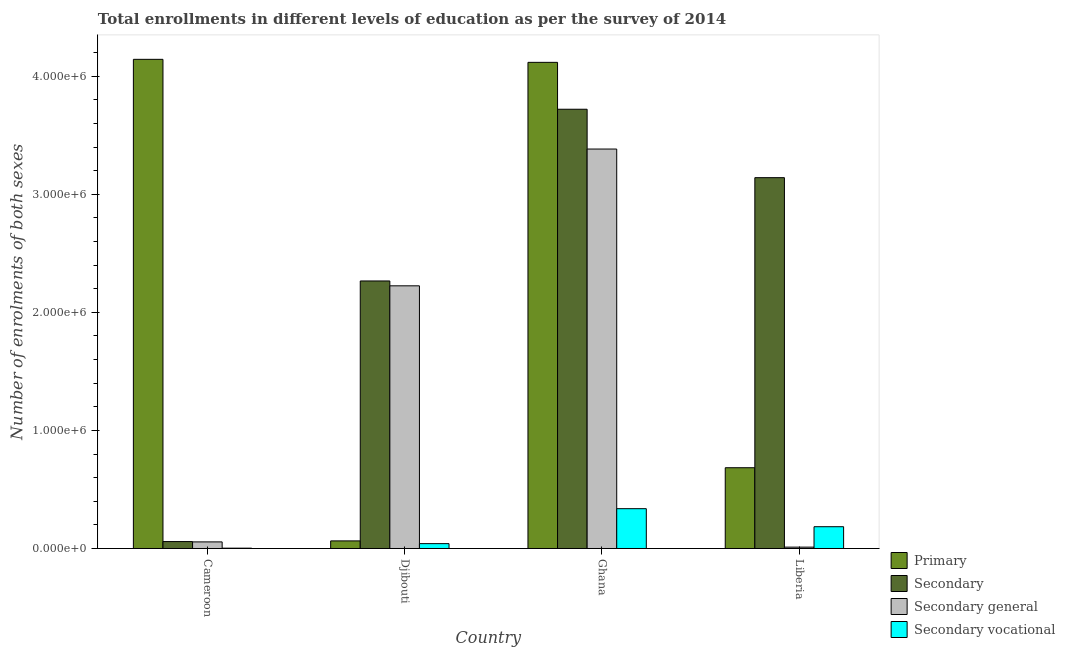Are the number of bars per tick equal to the number of legend labels?
Offer a terse response. Yes. Are the number of bars on each tick of the X-axis equal?
Your answer should be very brief. Yes. What is the label of the 4th group of bars from the left?
Make the answer very short. Liberia. What is the number of enrolments in secondary vocational education in Ghana?
Keep it short and to the point. 3.37e+05. Across all countries, what is the maximum number of enrolments in secondary education?
Give a very brief answer. 3.72e+06. Across all countries, what is the minimum number of enrolments in secondary education?
Make the answer very short. 5.86e+04. In which country was the number of enrolments in secondary education maximum?
Provide a short and direct response. Ghana. In which country was the number of enrolments in secondary vocational education minimum?
Provide a short and direct response. Cameroon. What is the total number of enrolments in secondary vocational education in the graph?
Your answer should be compact. 5.65e+05. What is the difference between the number of enrolments in secondary education in Cameroon and that in Liberia?
Make the answer very short. -3.08e+06. What is the difference between the number of enrolments in secondary vocational education in Ghana and the number of enrolments in secondary education in Djibouti?
Your response must be concise. -1.93e+06. What is the average number of enrolments in primary education per country?
Provide a succinct answer. 2.25e+06. What is the difference between the number of enrolments in primary education and number of enrolments in secondary general education in Cameroon?
Make the answer very short. 4.09e+06. What is the ratio of the number of enrolments in secondary education in Cameroon to that in Liberia?
Give a very brief answer. 0.02. Is the difference between the number of enrolments in secondary education in Ghana and Liberia greater than the difference between the number of enrolments in secondary general education in Ghana and Liberia?
Ensure brevity in your answer.  No. What is the difference between the highest and the second highest number of enrolments in secondary education?
Make the answer very short. 5.80e+05. What is the difference between the highest and the lowest number of enrolments in secondary education?
Make the answer very short. 3.66e+06. In how many countries, is the number of enrolments in secondary vocational education greater than the average number of enrolments in secondary vocational education taken over all countries?
Offer a terse response. 2. Is it the case that in every country, the sum of the number of enrolments in secondary education and number of enrolments in secondary vocational education is greater than the sum of number of enrolments in primary education and number of enrolments in secondary general education?
Offer a terse response. No. What does the 1st bar from the left in Djibouti represents?
Ensure brevity in your answer.  Primary. What does the 1st bar from the right in Djibouti represents?
Your response must be concise. Secondary vocational. Is it the case that in every country, the sum of the number of enrolments in primary education and number of enrolments in secondary education is greater than the number of enrolments in secondary general education?
Ensure brevity in your answer.  Yes. How many bars are there?
Make the answer very short. 16. Are all the bars in the graph horizontal?
Keep it short and to the point. No. Are the values on the major ticks of Y-axis written in scientific E-notation?
Give a very brief answer. Yes. Does the graph contain any zero values?
Your response must be concise. No. Where does the legend appear in the graph?
Provide a succinct answer. Bottom right. How many legend labels are there?
Make the answer very short. 4. How are the legend labels stacked?
Offer a terse response. Vertical. What is the title of the graph?
Provide a succinct answer. Total enrollments in different levels of education as per the survey of 2014. What is the label or title of the X-axis?
Ensure brevity in your answer.  Country. What is the label or title of the Y-axis?
Make the answer very short. Number of enrolments of both sexes. What is the Number of enrolments of both sexes in Primary in Cameroon?
Give a very brief answer. 4.14e+06. What is the Number of enrolments of both sexes in Secondary in Cameroon?
Ensure brevity in your answer.  5.86e+04. What is the Number of enrolments of both sexes of Secondary general in Cameroon?
Provide a succinct answer. 5.58e+04. What is the Number of enrolments of both sexes of Secondary vocational in Cameroon?
Provide a short and direct response. 2728. What is the Number of enrolments of both sexes in Primary in Djibouti?
Provide a short and direct response. 6.43e+04. What is the Number of enrolments of both sexes of Secondary in Djibouti?
Make the answer very short. 2.27e+06. What is the Number of enrolments of both sexes in Secondary general in Djibouti?
Your response must be concise. 2.22e+06. What is the Number of enrolments of both sexes in Secondary vocational in Djibouti?
Give a very brief answer. 4.11e+04. What is the Number of enrolments of both sexes of Primary in Ghana?
Provide a short and direct response. 4.12e+06. What is the Number of enrolments of both sexes in Secondary in Ghana?
Offer a terse response. 3.72e+06. What is the Number of enrolments of both sexes in Secondary general in Ghana?
Keep it short and to the point. 3.38e+06. What is the Number of enrolments of both sexes in Secondary vocational in Ghana?
Your answer should be compact. 3.37e+05. What is the Number of enrolments of both sexes in Primary in Liberia?
Make the answer very short. 6.84e+05. What is the Number of enrolments of both sexes in Secondary in Liberia?
Your response must be concise. 3.14e+06. What is the Number of enrolments of both sexes in Secondary general in Liberia?
Give a very brief answer. 1.14e+04. What is the Number of enrolments of both sexes of Secondary vocational in Liberia?
Your answer should be very brief. 1.84e+05. Across all countries, what is the maximum Number of enrolments of both sexes in Primary?
Your response must be concise. 4.14e+06. Across all countries, what is the maximum Number of enrolments of both sexes of Secondary?
Give a very brief answer. 3.72e+06. Across all countries, what is the maximum Number of enrolments of both sexes in Secondary general?
Make the answer very short. 3.38e+06. Across all countries, what is the maximum Number of enrolments of both sexes in Secondary vocational?
Your answer should be compact. 3.37e+05. Across all countries, what is the minimum Number of enrolments of both sexes in Primary?
Offer a very short reply. 6.43e+04. Across all countries, what is the minimum Number of enrolments of both sexes in Secondary?
Give a very brief answer. 5.86e+04. Across all countries, what is the minimum Number of enrolments of both sexes of Secondary general?
Your response must be concise. 1.14e+04. Across all countries, what is the minimum Number of enrolments of both sexes in Secondary vocational?
Keep it short and to the point. 2728. What is the total Number of enrolments of both sexes of Primary in the graph?
Make the answer very short. 9.01e+06. What is the total Number of enrolments of both sexes in Secondary in the graph?
Make the answer very short. 9.18e+06. What is the total Number of enrolments of both sexes in Secondary general in the graph?
Make the answer very short. 5.67e+06. What is the total Number of enrolments of both sexes of Secondary vocational in the graph?
Offer a terse response. 5.65e+05. What is the difference between the Number of enrolments of both sexes of Primary in Cameroon and that in Djibouti?
Give a very brief answer. 4.08e+06. What is the difference between the Number of enrolments of both sexes in Secondary in Cameroon and that in Djibouti?
Make the answer very short. -2.21e+06. What is the difference between the Number of enrolments of both sexes in Secondary general in Cameroon and that in Djibouti?
Give a very brief answer. -2.17e+06. What is the difference between the Number of enrolments of both sexes of Secondary vocational in Cameroon and that in Djibouti?
Your response must be concise. -3.83e+04. What is the difference between the Number of enrolments of both sexes of Primary in Cameroon and that in Ghana?
Your response must be concise. 2.56e+04. What is the difference between the Number of enrolments of both sexes in Secondary in Cameroon and that in Ghana?
Offer a terse response. -3.66e+06. What is the difference between the Number of enrolments of both sexes in Secondary general in Cameroon and that in Ghana?
Your response must be concise. -3.33e+06. What is the difference between the Number of enrolments of both sexes of Secondary vocational in Cameroon and that in Ghana?
Provide a succinct answer. -3.34e+05. What is the difference between the Number of enrolments of both sexes of Primary in Cameroon and that in Liberia?
Provide a succinct answer. 3.46e+06. What is the difference between the Number of enrolments of both sexes of Secondary in Cameroon and that in Liberia?
Provide a short and direct response. -3.08e+06. What is the difference between the Number of enrolments of both sexes of Secondary general in Cameroon and that in Liberia?
Ensure brevity in your answer.  4.44e+04. What is the difference between the Number of enrolments of both sexes in Secondary vocational in Cameroon and that in Liberia?
Your answer should be compact. -1.82e+05. What is the difference between the Number of enrolments of both sexes in Primary in Djibouti and that in Ghana?
Make the answer very short. -4.05e+06. What is the difference between the Number of enrolments of both sexes in Secondary in Djibouti and that in Ghana?
Keep it short and to the point. -1.45e+06. What is the difference between the Number of enrolments of both sexes in Secondary general in Djibouti and that in Ghana?
Give a very brief answer. -1.16e+06. What is the difference between the Number of enrolments of both sexes in Secondary vocational in Djibouti and that in Ghana?
Offer a terse response. -2.96e+05. What is the difference between the Number of enrolments of both sexes in Primary in Djibouti and that in Liberia?
Your answer should be compact. -6.20e+05. What is the difference between the Number of enrolments of both sexes in Secondary in Djibouti and that in Liberia?
Your response must be concise. -8.75e+05. What is the difference between the Number of enrolments of both sexes in Secondary general in Djibouti and that in Liberia?
Give a very brief answer. 2.21e+06. What is the difference between the Number of enrolments of both sexes in Secondary vocational in Djibouti and that in Liberia?
Ensure brevity in your answer.  -1.43e+05. What is the difference between the Number of enrolments of both sexes of Primary in Ghana and that in Liberia?
Provide a short and direct response. 3.43e+06. What is the difference between the Number of enrolments of both sexes in Secondary in Ghana and that in Liberia?
Make the answer very short. 5.80e+05. What is the difference between the Number of enrolments of both sexes in Secondary general in Ghana and that in Liberia?
Your response must be concise. 3.37e+06. What is the difference between the Number of enrolments of both sexes in Secondary vocational in Ghana and that in Liberia?
Provide a short and direct response. 1.53e+05. What is the difference between the Number of enrolments of both sexes in Primary in Cameroon and the Number of enrolments of both sexes in Secondary in Djibouti?
Give a very brief answer. 1.88e+06. What is the difference between the Number of enrolments of both sexes in Primary in Cameroon and the Number of enrolments of both sexes in Secondary general in Djibouti?
Your answer should be compact. 1.92e+06. What is the difference between the Number of enrolments of both sexes of Primary in Cameroon and the Number of enrolments of both sexes of Secondary vocational in Djibouti?
Ensure brevity in your answer.  4.10e+06. What is the difference between the Number of enrolments of both sexes of Secondary in Cameroon and the Number of enrolments of both sexes of Secondary general in Djibouti?
Your answer should be compact. -2.17e+06. What is the difference between the Number of enrolments of both sexes in Secondary in Cameroon and the Number of enrolments of both sexes in Secondary vocational in Djibouti?
Give a very brief answer. 1.75e+04. What is the difference between the Number of enrolments of both sexes of Secondary general in Cameroon and the Number of enrolments of both sexes of Secondary vocational in Djibouti?
Provide a short and direct response. 1.48e+04. What is the difference between the Number of enrolments of both sexes of Primary in Cameroon and the Number of enrolments of both sexes of Secondary in Ghana?
Offer a very short reply. 4.23e+05. What is the difference between the Number of enrolments of both sexes of Primary in Cameroon and the Number of enrolments of both sexes of Secondary general in Ghana?
Make the answer very short. 7.60e+05. What is the difference between the Number of enrolments of both sexes in Primary in Cameroon and the Number of enrolments of both sexes in Secondary vocational in Ghana?
Offer a very short reply. 3.81e+06. What is the difference between the Number of enrolments of both sexes in Secondary in Cameroon and the Number of enrolments of both sexes in Secondary general in Ghana?
Keep it short and to the point. -3.32e+06. What is the difference between the Number of enrolments of both sexes of Secondary in Cameroon and the Number of enrolments of both sexes of Secondary vocational in Ghana?
Your answer should be compact. -2.79e+05. What is the difference between the Number of enrolments of both sexes in Secondary general in Cameroon and the Number of enrolments of both sexes in Secondary vocational in Ghana?
Provide a succinct answer. -2.81e+05. What is the difference between the Number of enrolments of both sexes of Primary in Cameroon and the Number of enrolments of both sexes of Secondary in Liberia?
Your response must be concise. 1.00e+06. What is the difference between the Number of enrolments of both sexes of Primary in Cameroon and the Number of enrolments of both sexes of Secondary general in Liberia?
Offer a very short reply. 4.13e+06. What is the difference between the Number of enrolments of both sexes in Primary in Cameroon and the Number of enrolments of both sexes in Secondary vocational in Liberia?
Your answer should be very brief. 3.96e+06. What is the difference between the Number of enrolments of both sexes in Secondary in Cameroon and the Number of enrolments of both sexes in Secondary general in Liberia?
Provide a succinct answer. 4.71e+04. What is the difference between the Number of enrolments of both sexes in Secondary in Cameroon and the Number of enrolments of both sexes in Secondary vocational in Liberia?
Provide a short and direct response. -1.26e+05. What is the difference between the Number of enrolments of both sexes in Secondary general in Cameroon and the Number of enrolments of both sexes in Secondary vocational in Liberia?
Offer a terse response. -1.29e+05. What is the difference between the Number of enrolments of both sexes of Primary in Djibouti and the Number of enrolments of both sexes of Secondary in Ghana?
Give a very brief answer. -3.66e+06. What is the difference between the Number of enrolments of both sexes in Primary in Djibouti and the Number of enrolments of both sexes in Secondary general in Ghana?
Keep it short and to the point. -3.32e+06. What is the difference between the Number of enrolments of both sexes of Primary in Djibouti and the Number of enrolments of both sexes of Secondary vocational in Ghana?
Keep it short and to the point. -2.73e+05. What is the difference between the Number of enrolments of both sexes of Secondary in Djibouti and the Number of enrolments of both sexes of Secondary general in Ghana?
Offer a very short reply. -1.12e+06. What is the difference between the Number of enrolments of both sexes of Secondary in Djibouti and the Number of enrolments of both sexes of Secondary vocational in Ghana?
Give a very brief answer. 1.93e+06. What is the difference between the Number of enrolments of both sexes in Secondary general in Djibouti and the Number of enrolments of both sexes in Secondary vocational in Ghana?
Offer a terse response. 1.89e+06. What is the difference between the Number of enrolments of both sexes of Primary in Djibouti and the Number of enrolments of both sexes of Secondary in Liberia?
Provide a short and direct response. -3.08e+06. What is the difference between the Number of enrolments of both sexes in Primary in Djibouti and the Number of enrolments of both sexes in Secondary general in Liberia?
Ensure brevity in your answer.  5.29e+04. What is the difference between the Number of enrolments of both sexes in Primary in Djibouti and the Number of enrolments of both sexes in Secondary vocational in Liberia?
Your response must be concise. -1.20e+05. What is the difference between the Number of enrolments of both sexes in Secondary in Djibouti and the Number of enrolments of both sexes in Secondary general in Liberia?
Keep it short and to the point. 2.25e+06. What is the difference between the Number of enrolments of both sexes in Secondary in Djibouti and the Number of enrolments of both sexes in Secondary vocational in Liberia?
Keep it short and to the point. 2.08e+06. What is the difference between the Number of enrolments of both sexes of Secondary general in Djibouti and the Number of enrolments of both sexes of Secondary vocational in Liberia?
Your response must be concise. 2.04e+06. What is the difference between the Number of enrolments of both sexes of Primary in Ghana and the Number of enrolments of both sexes of Secondary in Liberia?
Ensure brevity in your answer.  9.77e+05. What is the difference between the Number of enrolments of both sexes of Primary in Ghana and the Number of enrolments of both sexes of Secondary general in Liberia?
Your answer should be compact. 4.11e+06. What is the difference between the Number of enrolments of both sexes in Primary in Ghana and the Number of enrolments of both sexes in Secondary vocational in Liberia?
Give a very brief answer. 3.93e+06. What is the difference between the Number of enrolments of both sexes in Secondary in Ghana and the Number of enrolments of both sexes in Secondary general in Liberia?
Ensure brevity in your answer.  3.71e+06. What is the difference between the Number of enrolments of both sexes in Secondary in Ghana and the Number of enrolments of both sexes in Secondary vocational in Liberia?
Offer a terse response. 3.54e+06. What is the difference between the Number of enrolments of both sexes of Secondary general in Ghana and the Number of enrolments of both sexes of Secondary vocational in Liberia?
Keep it short and to the point. 3.20e+06. What is the average Number of enrolments of both sexes of Primary per country?
Make the answer very short. 2.25e+06. What is the average Number of enrolments of both sexes in Secondary per country?
Offer a very short reply. 2.30e+06. What is the average Number of enrolments of both sexes in Secondary general per country?
Provide a succinct answer. 1.42e+06. What is the average Number of enrolments of both sexes of Secondary vocational per country?
Give a very brief answer. 1.41e+05. What is the difference between the Number of enrolments of both sexes of Primary and Number of enrolments of both sexes of Secondary in Cameroon?
Offer a very short reply. 4.08e+06. What is the difference between the Number of enrolments of both sexes in Primary and Number of enrolments of both sexes in Secondary general in Cameroon?
Ensure brevity in your answer.  4.09e+06. What is the difference between the Number of enrolments of both sexes in Primary and Number of enrolments of both sexes in Secondary vocational in Cameroon?
Ensure brevity in your answer.  4.14e+06. What is the difference between the Number of enrolments of both sexes of Secondary and Number of enrolments of both sexes of Secondary general in Cameroon?
Give a very brief answer. 2728. What is the difference between the Number of enrolments of both sexes in Secondary and Number of enrolments of both sexes in Secondary vocational in Cameroon?
Your answer should be compact. 5.58e+04. What is the difference between the Number of enrolments of both sexes in Secondary general and Number of enrolments of both sexes in Secondary vocational in Cameroon?
Offer a terse response. 5.31e+04. What is the difference between the Number of enrolments of both sexes in Primary and Number of enrolments of both sexes in Secondary in Djibouti?
Provide a short and direct response. -2.20e+06. What is the difference between the Number of enrolments of both sexes in Primary and Number of enrolments of both sexes in Secondary general in Djibouti?
Your answer should be compact. -2.16e+06. What is the difference between the Number of enrolments of both sexes of Primary and Number of enrolments of both sexes of Secondary vocational in Djibouti?
Give a very brief answer. 2.33e+04. What is the difference between the Number of enrolments of both sexes of Secondary and Number of enrolments of both sexes of Secondary general in Djibouti?
Give a very brief answer. 4.11e+04. What is the difference between the Number of enrolments of both sexes of Secondary and Number of enrolments of both sexes of Secondary vocational in Djibouti?
Offer a terse response. 2.22e+06. What is the difference between the Number of enrolments of both sexes in Secondary general and Number of enrolments of both sexes in Secondary vocational in Djibouti?
Keep it short and to the point. 2.18e+06. What is the difference between the Number of enrolments of both sexes in Primary and Number of enrolments of both sexes in Secondary in Ghana?
Your answer should be very brief. 3.97e+05. What is the difference between the Number of enrolments of both sexes in Primary and Number of enrolments of both sexes in Secondary general in Ghana?
Make the answer very short. 7.34e+05. What is the difference between the Number of enrolments of both sexes in Primary and Number of enrolments of both sexes in Secondary vocational in Ghana?
Ensure brevity in your answer.  3.78e+06. What is the difference between the Number of enrolments of both sexes in Secondary and Number of enrolments of both sexes in Secondary general in Ghana?
Make the answer very short. 3.37e+05. What is the difference between the Number of enrolments of both sexes of Secondary and Number of enrolments of both sexes of Secondary vocational in Ghana?
Provide a succinct answer. 3.38e+06. What is the difference between the Number of enrolments of both sexes of Secondary general and Number of enrolments of both sexes of Secondary vocational in Ghana?
Your answer should be very brief. 3.05e+06. What is the difference between the Number of enrolments of both sexes of Primary and Number of enrolments of both sexes of Secondary in Liberia?
Provide a succinct answer. -2.46e+06. What is the difference between the Number of enrolments of both sexes of Primary and Number of enrolments of both sexes of Secondary general in Liberia?
Your response must be concise. 6.73e+05. What is the difference between the Number of enrolments of both sexes in Primary and Number of enrolments of both sexes in Secondary vocational in Liberia?
Make the answer very short. 5.00e+05. What is the difference between the Number of enrolments of both sexes of Secondary and Number of enrolments of both sexes of Secondary general in Liberia?
Give a very brief answer. 3.13e+06. What is the difference between the Number of enrolments of both sexes in Secondary and Number of enrolments of both sexes in Secondary vocational in Liberia?
Provide a succinct answer. 2.96e+06. What is the difference between the Number of enrolments of both sexes in Secondary general and Number of enrolments of both sexes in Secondary vocational in Liberia?
Make the answer very short. -1.73e+05. What is the ratio of the Number of enrolments of both sexes of Primary in Cameroon to that in Djibouti?
Keep it short and to the point. 64.41. What is the ratio of the Number of enrolments of both sexes in Secondary in Cameroon to that in Djibouti?
Ensure brevity in your answer.  0.03. What is the ratio of the Number of enrolments of both sexes in Secondary general in Cameroon to that in Djibouti?
Provide a succinct answer. 0.03. What is the ratio of the Number of enrolments of both sexes in Secondary vocational in Cameroon to that in Djibouti?
Your answer should be very brief. 0.07. What is the ratio of the Number of enrolments of both sexes in Secondary in Cameroon to that in Ghana?
Ensure brevity in your answer.  0.02. What is the ratio of the Number of enrolments of both sexes of Secondary general in Cameroon to that in Ghana?
Give a very brief answer. 0.02. What is the ratio of the Number of enrolments of both sexes in Secondary vocational in Cameroon to that in Ghana?
Offer a terse response. 0.01. What is the ratio of the Number of enrolments of both sexes in Primary in Cameroon to that in Liberia?
Offer a terse response. 6.06. What is the ratio of the Number of enrolments of both sexes of Secondary in Cameroon to that in Liberia?
Provide a succinct answer. 0.02. What is the ratio of the Number of enrolments of both sexes in Secondary general in Cameroon to that in Liberia?
Provide a succinct answer. 4.88. What is the ratio of the Number of enrolments of both sexes of Secondary vocational in Cameroon to that in Liberia?
Your answer should be very brief. 0.01. What is the ratio of the Number of enrolments of both sexes of Primary in Djibouti to that in Ghana?
Give a very brief answer. 0.02. What is the ratio of the Number of enrolments of both sexes in Secondary in Djibouti to that in Ghana?
Keep it short and to the point. 0.61. What is the ratio of the Number of enrolments of both sexes of Secondary general in Djibouti to that in Ghana?
Your response must be concise. 0.66. What is the ratio of the Number of enrolments of both sexes in Secondary vocational in Djibouti to that in Ghana?
Offer a very short reply. 0.12. What is the ratio of the Number of enrolments of both sexes of Primary in Djibouti to that in Liberia?
Offer a very short reply. 0.09. What is the ratio of the Number of enrolments of both sexes of Secondary in Djibouti to that in Liberia?
Give a very brief answer. 0.72. What is the ratio of the Number of enrolments of both sexes in Secondary general in Djibouti to that in Liberia?
Keep it short and to the point. 194.66. What is the ratio of the Number of enrolments of both sexes of Secondary vocational in Djibouti to that in Liberia?
Give a very brief answer. 0.22. What is the ratio of the Number of enrolments of both sexes of Primary in Ghana to that in Liberia?
Offer a very short reply. 6.02. What is the ratio of the Number of enrolments of both sexes in Secondary in Ghana to that in Liberia?
Give a very brief answer. 1.18. What is the ratio of the Number of enrolments of both sexes in Secondary general in Ghana to that in Liberia?
Give a very brief answer. 296.03. What is the ratio of the Number of enrolments of both sexes in Secondary vocational in Ghana to that in Liberia?
Make the answer very short. 1.83. What is the difference between the highest and the second highest Number of enrolments of both sexes of Primary?
Your answer should be compact. 2.56e+04. What is the difference between the highest and the second highest Number of enrolments of both sexes in Secondary?
Your answer should be compact. 5.80e+05. What is the difference between the highest and the second highest Number of enrolments of both sexes of Secondary general?
Provide a short and direct response. 1.16e+06. What is the difference between the highest and the second highest Number of enrolments of both sexes of Secondary vocational?
Your answer should be very brief. 1.53e+05. What is the difference between the highest and the lowest Number of enrolments of both sexes of Primary?
Offer a terse response. 4.08e+06. What is the difference between the highest and the lowest Number of enrolments of both sexes of Secondary?
Give a very brief answer. 3.66e+06. What is the difference between the highest and the lowest Number of enrolments of both sexes in Secondary general?
Your response must be concise. 3.37e+06. What is the difference between the highest and the lowest Number of enrolments of both sexes of Secondary vocational?
Offer a very short reply. 3.34e+05. 